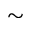Convert formula to latex. <formula><loc_0><loc_0><loc_500><loc_500>\sim</formula> 